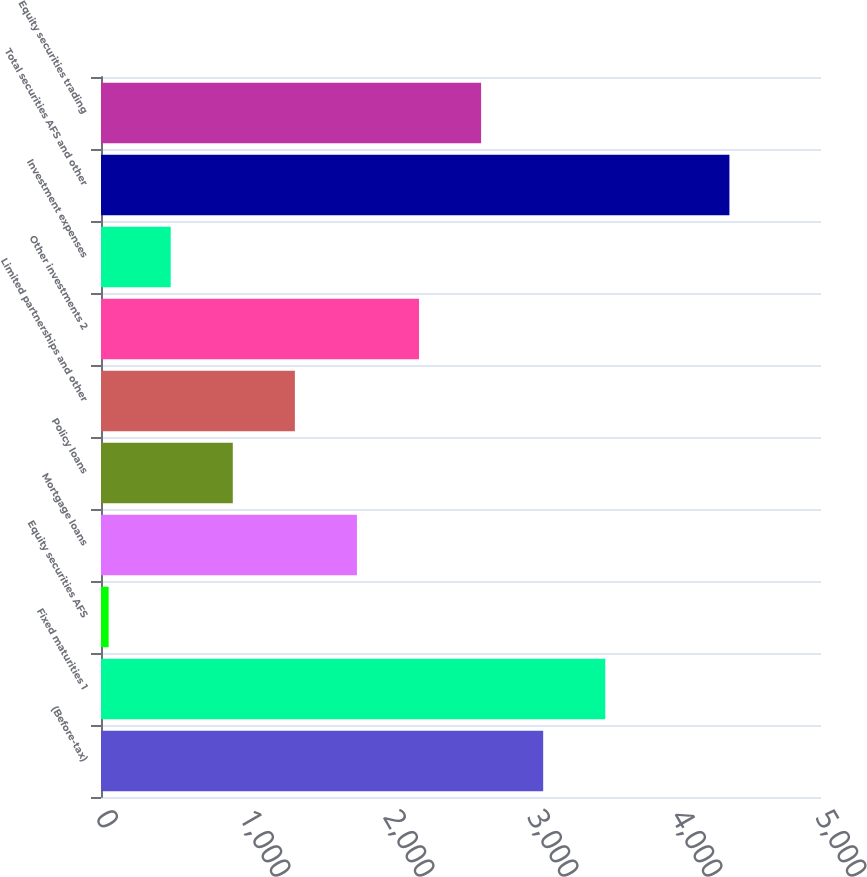<chart> <loc_0><loc_0><loc_500><loc_500><bar_chart><fcel>(Before-tax)<fcel>Fixed maturities 1<fcel>Equity securities AFS<fcel>Mortgage loans<fcel>Policy loans<fcel>Limited partnerships and other<fcel>Other investments 2<fcel>Investment expenses<fcel>Total securities AFS and other<fcel>Equity securities trading<nl><fcel>3070.7<fcel>3501.8<fcel>53<fcel>1777.4<fcel>915.2<fcel>1346.3<fcel>2208.5<fcel>484.1<fcel>4364<fcel>2639.6<nl></chart> 